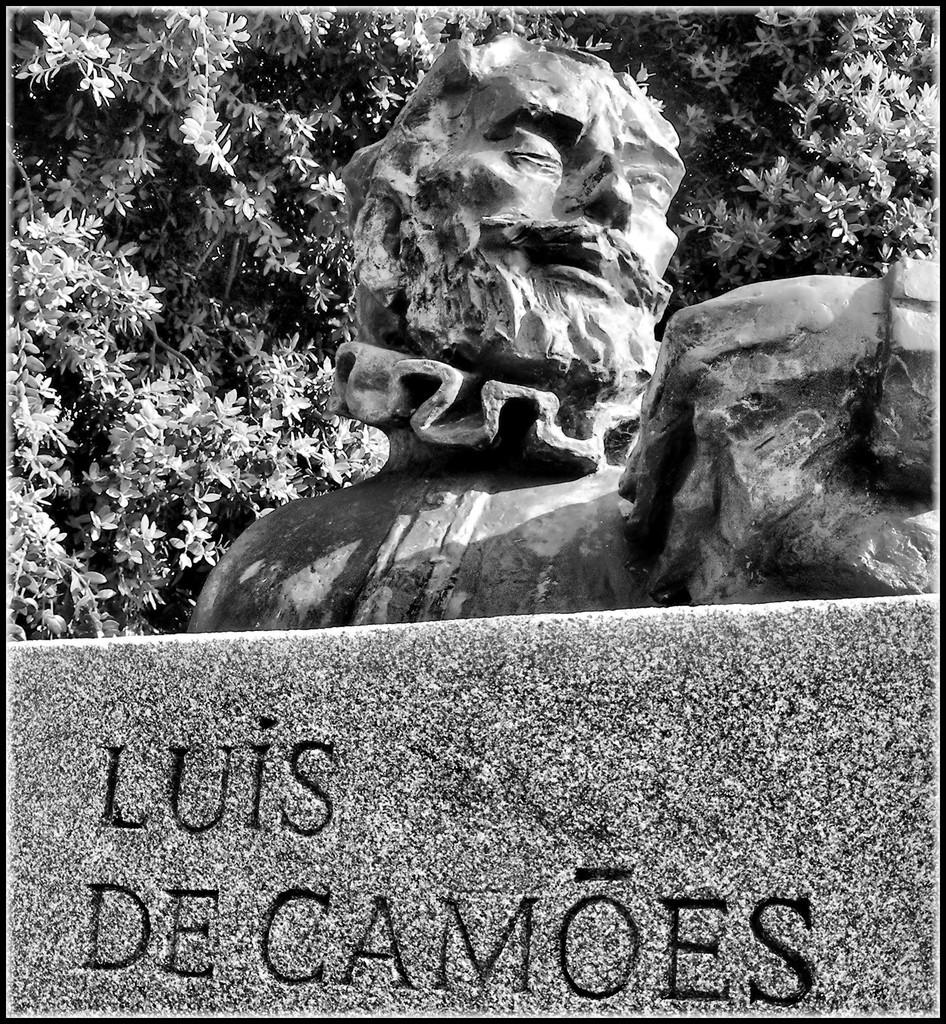What is the color scheme of the image? The image is black and white. What is the main subject in the image? There is a statue in the image. What is the statue standing on? The statue is on an object with some text. What type of natural environment can be seen in the image? There are trees visible in the image. Can you tell me how many snakes are wrapped around the statue in the image? There are no snakes present in the image; it features a statue standing on an object with text. What invention is the statue holding in the image? There is no invention visible in the image; it only shows a statue standing on an object with text and trees in the background. 